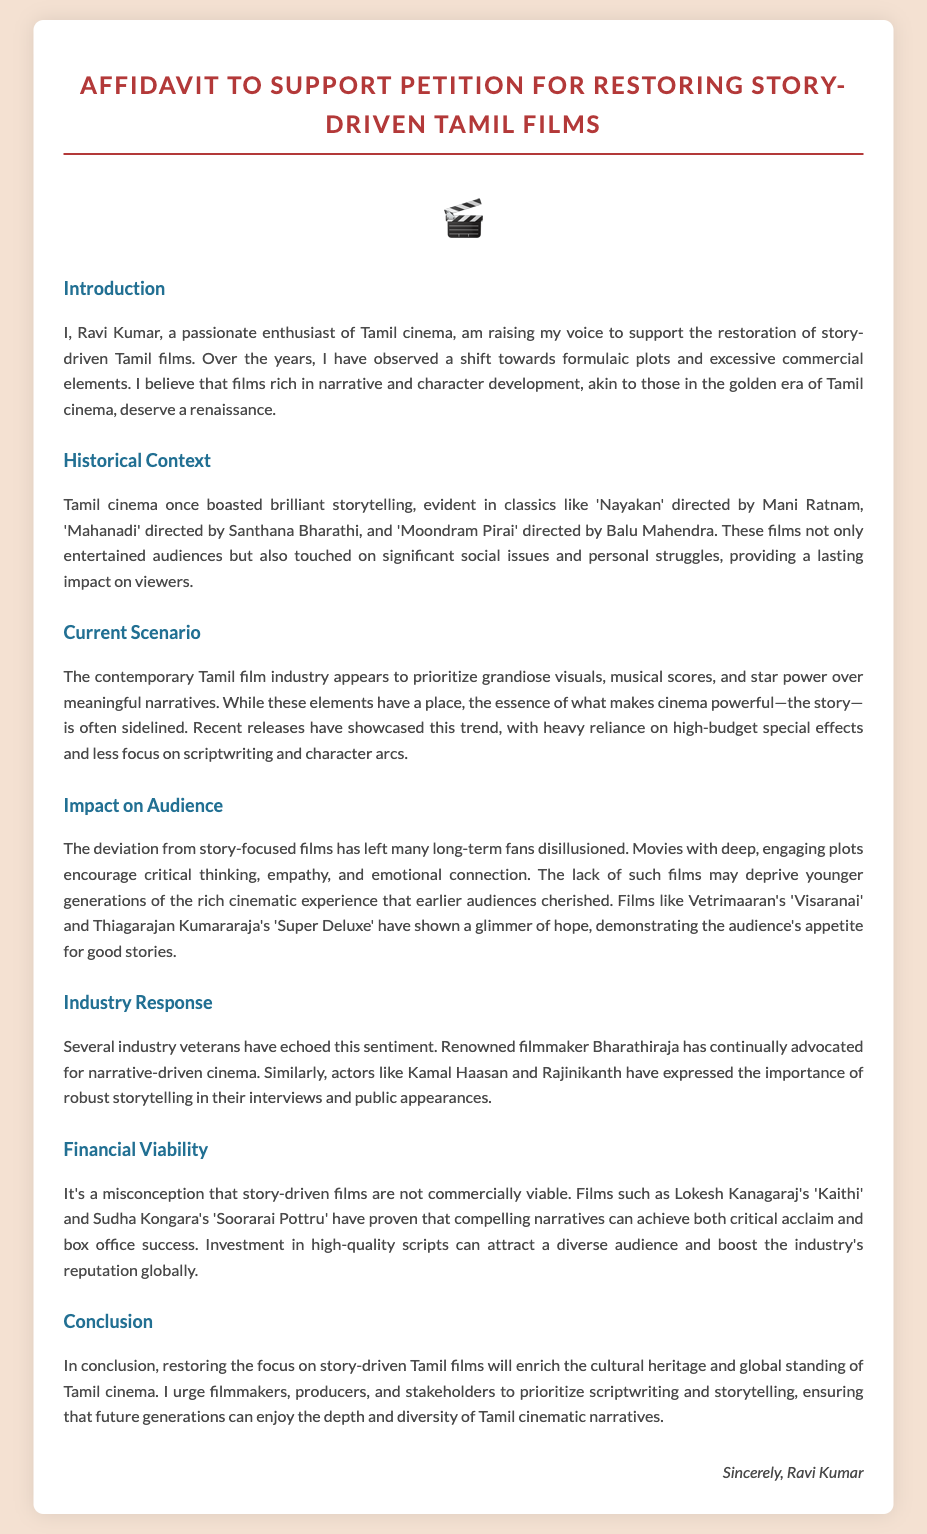what is the name of the petitioner? The petitioner is identified as Ravi Kumar in the document.
Answer: Ravi Kumar which classic Tamil film is mentioned as directed by Mani Ratnam? The document mentions 'Nayakan' directed by Mani Ratnam as a classic Tamil film.
Answer: Nayakan who is quoted as advocating for narrative-driven cinema? The document states that renowned filmmaker Bharathiraja has advocated for narrative-driven cinema.
Answer: Bharathiraja what are the two recent films mentioned that showcase good storytelling? The affidavit references 'Visaranai' and 'Super Deluxe' as films showing good storytelling.
Answer: Visaranai, Super Deluxe how many films are cited as examples of commercially successful story-driven films? The document provides two examples: 'Kaithi' and 'Soorarai Pottru' as commercially successful story-driven films.
Answer: Two what is the purpose of this affidavit? The purpose of the affidavit is to support the restoration of story-driven Tamil films.
Answer: Restoration of story-driven Tamil films what industry response is noted regarding storytelling? The document states that actors like Kamal Haasan and Rajinikanth express the importance of robust storytelling.
Answer: Kamal Haasan, Rajinikanth what has the contemporary Tamil film industry prioritized over meaningful narratives? The affidavit mentions that the contemporary industry prioritizes grandiose visuals and star power.
Answer: Grandiose visuals and star power 